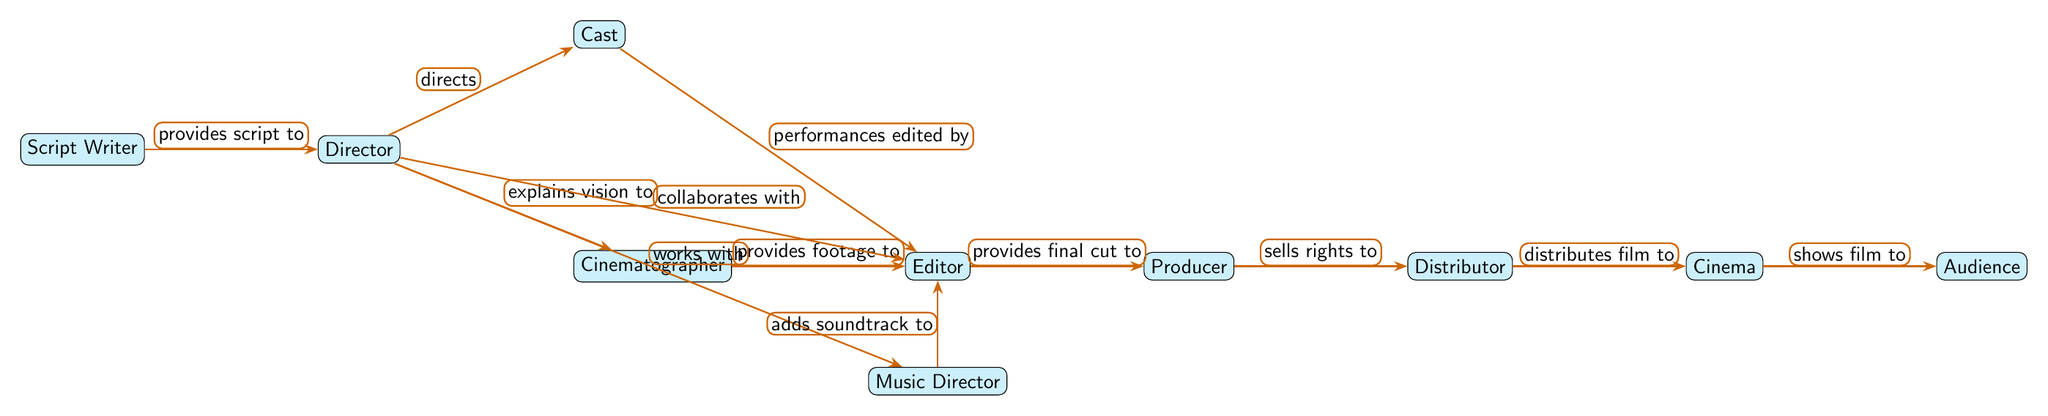What is the first department involved in the nutrient cycle? The diagram shows the first department as the Script Writer, which is the starting point of the flow as it provides the script to the Director.
Answer: Script Writer How many departments are directly connected to the Director? The Director is directly connected to three departments: the Script Writer, the Cinematographer, and the Cast, based on the arrows emanating from the Director node.
Answer: 3 What does the Editor receive from the Cinematographer? According to the diagram, the Editor receives footage from the Cinematographer as indicated by the directed arrow and label "provides footage to".
Answer: Footage Who collaborates with the Editor? The diagram indicates that both the Director and the Cast collaborate with the Editor, specifically noted on their respective arrows leading to the Editor node.
Answer: Director, Cast Which department adds soundtrack to the Editor? The flow states that the Music Director adds the soundtrack to the Editor, as per the directed arrow labeled "adds soundtrack to".
Answer: Music Director What is the final recipient of the film after the Producer? The final recipient of the film, after it is sold by the Producer, is the Distributor, as indicated by the connection "+sells rights to" from the Producer to the Distributor node.
Answer: Distributor What does the Distributor do with the film? The Distributor distributes the film to the Cinema, clearly shown through the directed arrow and label connecting them in the diagram.
Answer: Distributes film How does the Audience get to see the film? The Audience sees the film after it is shown in the Cinema, as depicted by the arrow labeled "shows film to", making the Cinema the last department before reaching the Audience.
Answer: Cinema What direction does the flow in the diagram follow? The flow in the diagram follows a left-to-right direction, starting from the Script Writer and ending at the Audience, with arrows illustrating the connections between each department.
Answer: Left to Right 